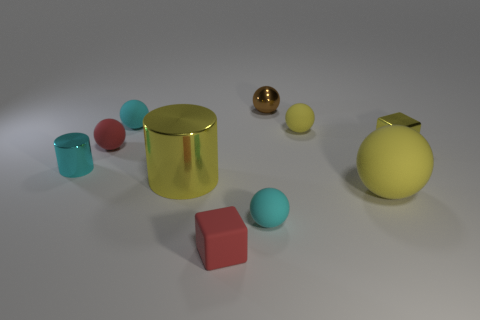Subtract all purple cylinders. How many cyan balls are left? 2 Subtract all brown spheres. How many spheres are left? 5 Subtract 2 spheres. How many spheres are left? 4 Subtract all red spheres. How many spheres are left? 5 Subtract all brown spheres. Subtract all purple cylinders. How many spheres are left? 5 Subtract 1 cyan cylinders. How many objects are left? 9 Subtract all cubes. How many objects are left? 8 Subtract all small blue metal things. Subtract all large yellow cylinders. How many objects are left? 9 Add 5 metallic objects. How many metallic objects are left? 9 Add 6 yellow shiny cylinders. How many yellow shiny cylinders exist? 7 